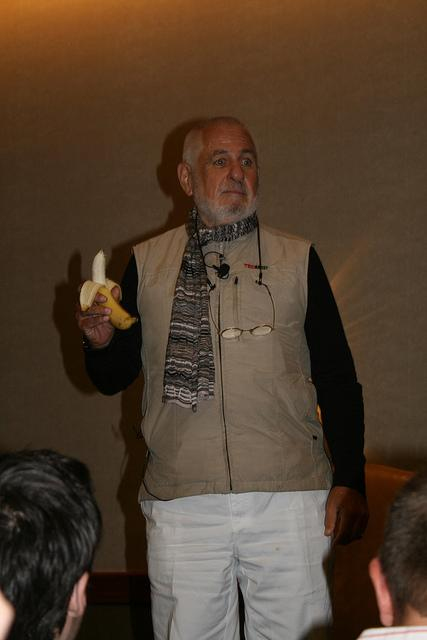What type of eyesight does the man standing here have? Please explain your reasoning. far sighted. The man can see far distances since he's not wearing them to look out into the distance. 